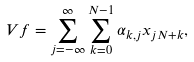Convert formula to latex. <formula><loc_0><loc_0><loc_500><loc_500>V f = \sum _ { j = - \infty } ^ { \infty } \sum _ { k = 0 } ^ { N - 1 } \alpha _ { k , j } x _ { j N + k } ,</formula> 